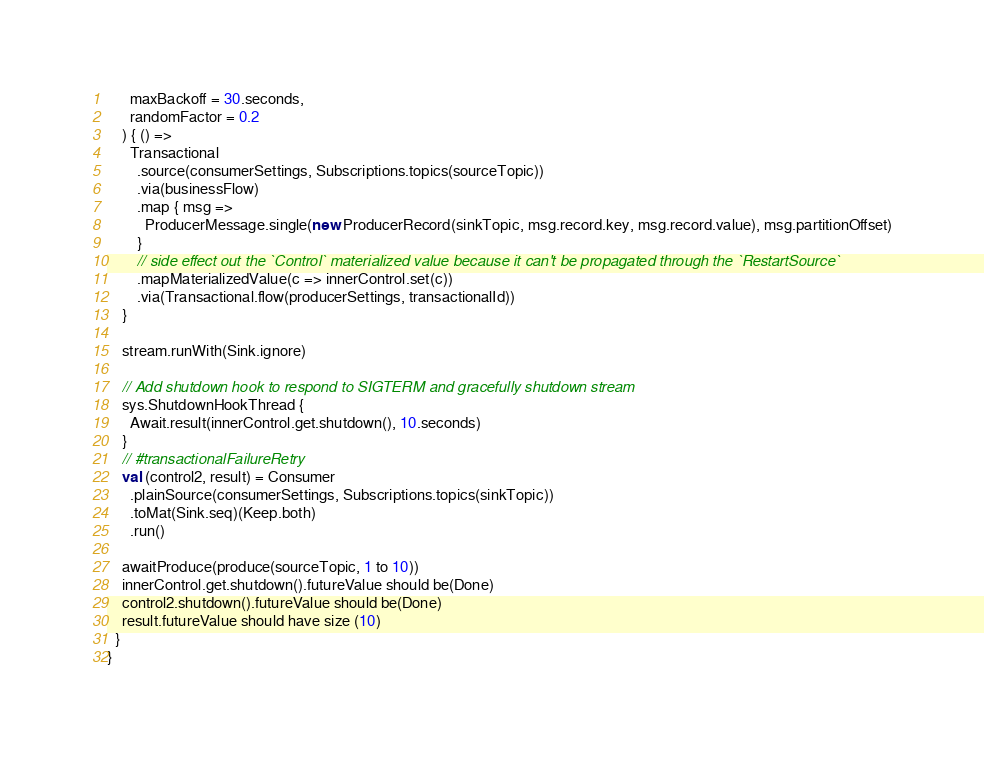Convert code to text. <code><loc_0><loc_0><loc_500><loc_500><_Scala_>      maxBackoff = 30.seconds,
      randomFactor = 0.2
    ) { () =>
      Transactional
        .source(consumerSettings, Subscriptions.topics(sourceTopic))
        .via(businessFlow)
        .map { msg =>
          ProducerMessage.single(new ProducerRecord(sinkTopic, msg.record.key, msg.record.value), msg.partitionOffset)
        }
        // side effect out the `Control` materialized value because it can't be propagated through the `RestartSource`
        .mapMaterializedValue(c => innerControl.set(c))
        .via(Transactional.flow(producerSettings, transactionalId))
    }

    stream.runWith(Sink.ignore)

    // Add shutdown hook to respond to SIGTERM and gracefully shutdown stream
    sys.ShutdownHookThread {
      Await.result(innerControl.get.shutdown(), 10.seconds)
    }
    // #transactionalFailureRetry
    val (control2, result) = Consumer
      .plainSource(consumerSettings, Subscriptions.topics(sinkTopic))
      .toMat(Sink.seq)(Keep.both)
      .run()

    awaitProduce(produce(sourceTopic, 1 to 10))
    innerControl.get.shutdown().futureValue should be(Done)
    control2.shutdown().futureValue should be(Done)
    result.futureValue should have size (10)
  }
}
</code> 